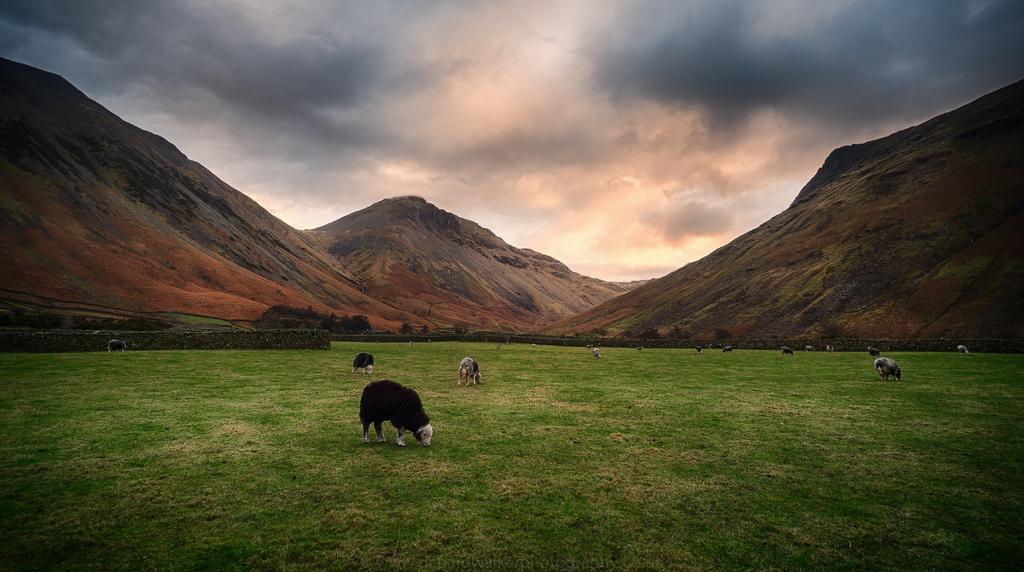Please provide a concise description of this image. In this image, we can see the ground covered with grass. There are a few animals. We can see the fence. There are some plants. We can see some hills. We can see the sky with clouds. 